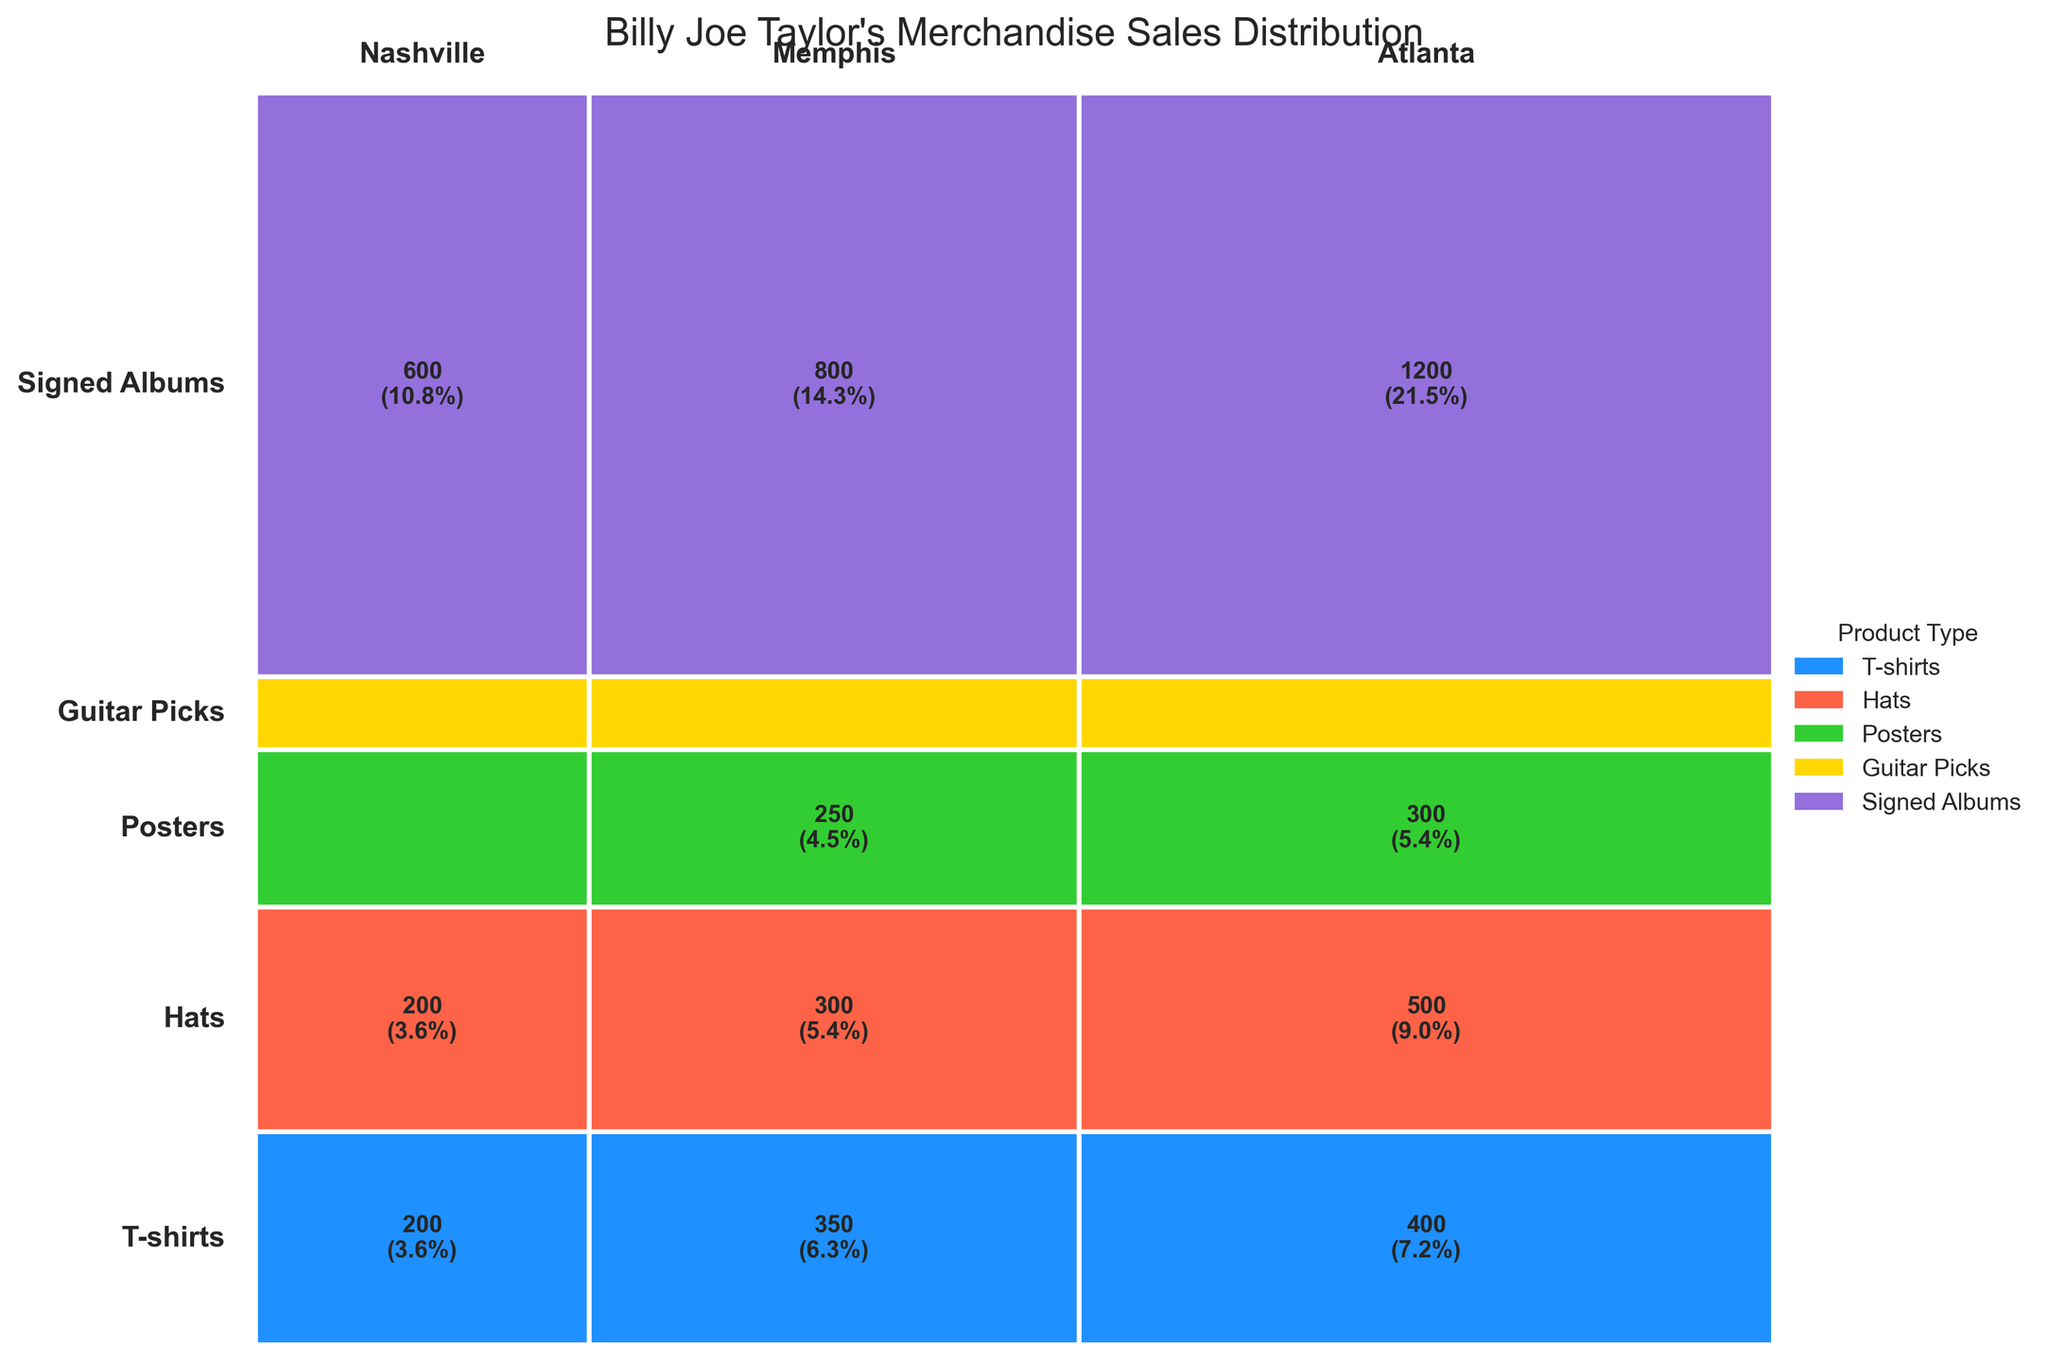Which customer location has the highest sales for T-shirts? Referring to the mosaic plot, the height corresponding to T-shirts for different customer locations shows that Nashville has the tallest segment, indicating the highest sales for T-shirts.
Answer: Nashville What is the total sales for Hats across all locations? Summing up the sales numbers for Hats in each location: Nashville (500), Memphis (300), and Atlanta (200), we get 500 + 300 + 200 = 1000.
Answer: 1000 Which product type has the smallest segment in the Nashville location? By looking at the widths of the segments for Nashville across different products, the smallest segment corresponds to Signed Albums.
Answer: Signed Albums Compare the sales of Posters between Nashville and Memphis. The mosaic plot shows sales for Posters as 300 in Nashville and 250 in Memphis. The segment for Nashville is slightly larger, indicating higher sales.
Answer: Nashville What percentage of the total sales does Guitar Picks in Memphis represent? To obtain this, calculate Guitar Picks sales in Memphis (350) divided by the total sales (total 4675, derived from adding all sales values) and then multiply by 100. (350 / 4675) * 100 ≈ 7.5%.
Answer: ~7.5% What is the difference in sales between T-shirts in Nashville and Atlanta? Referring to the segment heights for T-shirts, Nashville has 1200 sales, and Atlanta has 600 sales. The difference is 1200 - 600 = 600.
Answer: 600 Rank the product types by total sales from highest to lowest. By summing the sales across all locations for each product type: T-shirts (2600), Hats (1000), Posters (700), Guitar Picks (950), and Signed Albums (325). The ranking from highest to lowest is: T-shirts, Hats, Guitar Picks, Posters, Signed Albums.
Answer: T-shirts, Hats, Guitar Picks, Posters, Signed Albums Which product location combination has the smallest sales? By inspecting the smallest segments in the mosaic plot, Signed Albums in Atlanta has the smallest sales, which is 75.
Answer: Signed Albums in Atlanta How does the sales distribution for Posters in three locations compare to each other? The mosaic plot shows the segments for Posters are larger in Nashville (300), smaller in Memphis (250), and smallest in Atlanta (150). Hence, Posters sell the most in Nashville, followed by Memphis, and the least in Atlanta.
Answer: Nashville > Memphis > Atlanta 